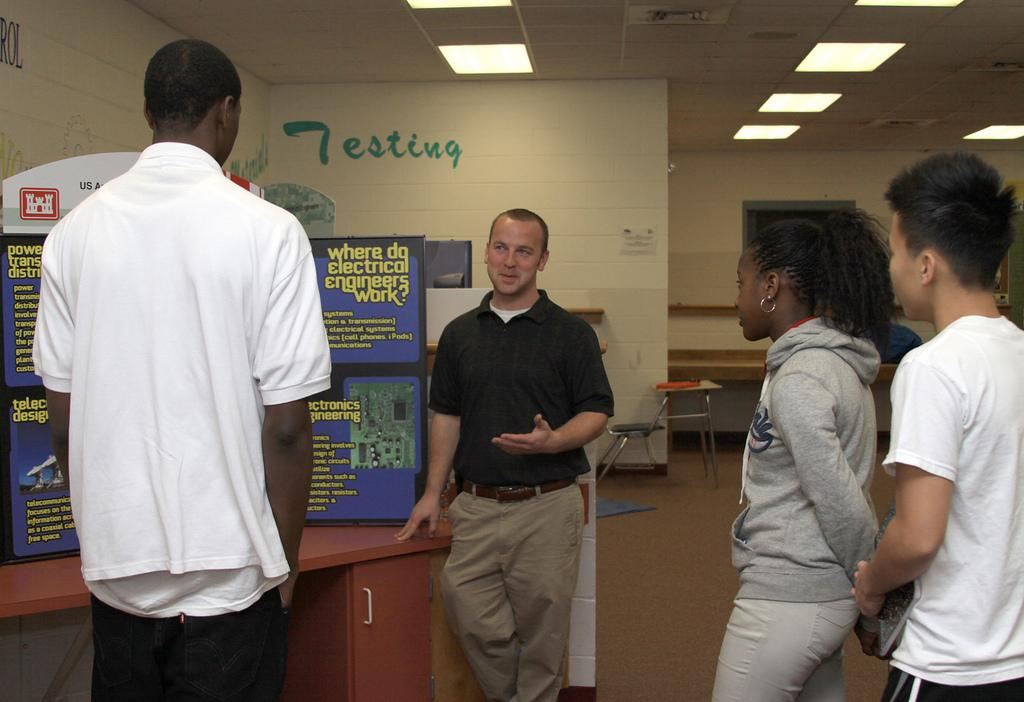How many people are present in the image? There are four people standing in the image. What can be seen on the walls in the image? There are posters in the image. What is visible in the background of the image? There is a wall in the background of the image. What is attached to the ceiling in the image? Lights are attached to the ceiling in the image. What type of coal is being used to fuel the rail in the image? There is no rail or coal present in the image. What are the hobbies of the people in the image? We cannot determine the hobbies of the people in the image based on the provided facts. 